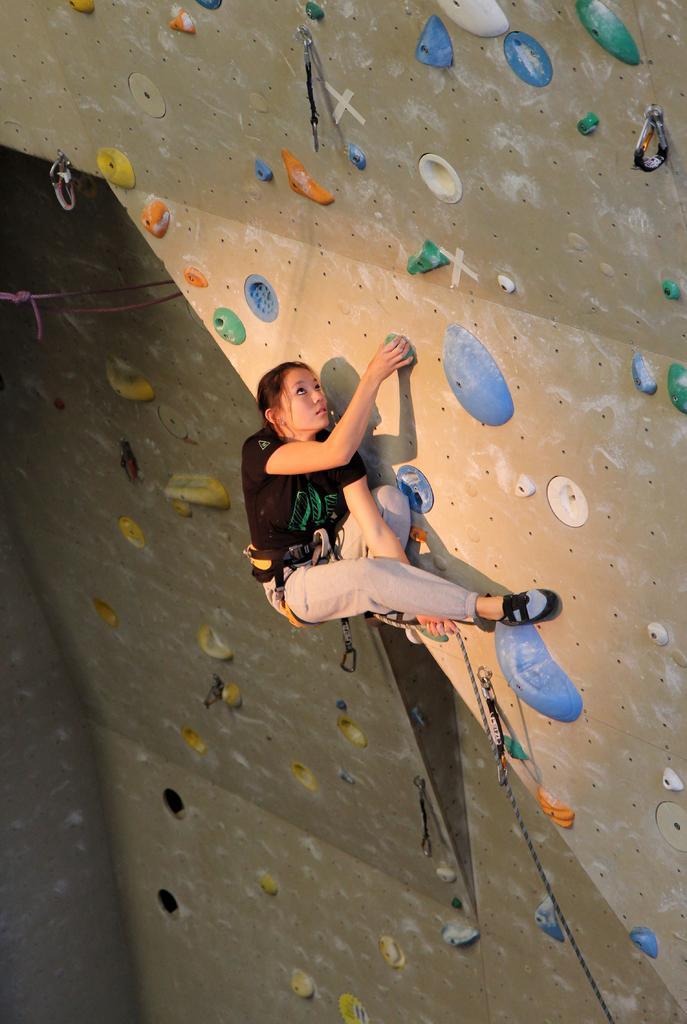How would you summarize this image in a sentence or two? In this picture we can see a girl bouldering here, there is a rope here, we can see a wall in the background. 